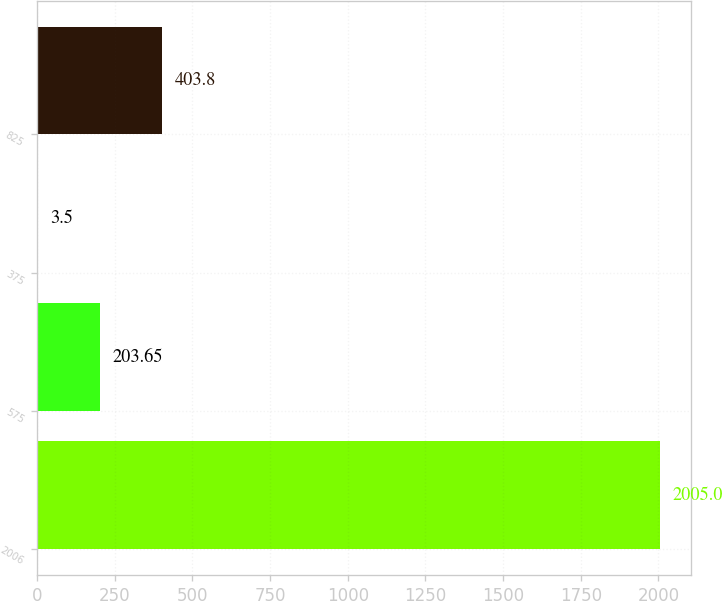<chart> <loc_0><loc_0><loc_500><loc_500><bar_chart><fcel>2006<fcel>575<fcel>375<fcel>825<nl><fcel>2005<fcel>203.65<fcel>3.5<fcel>403.8<nl></chart> 